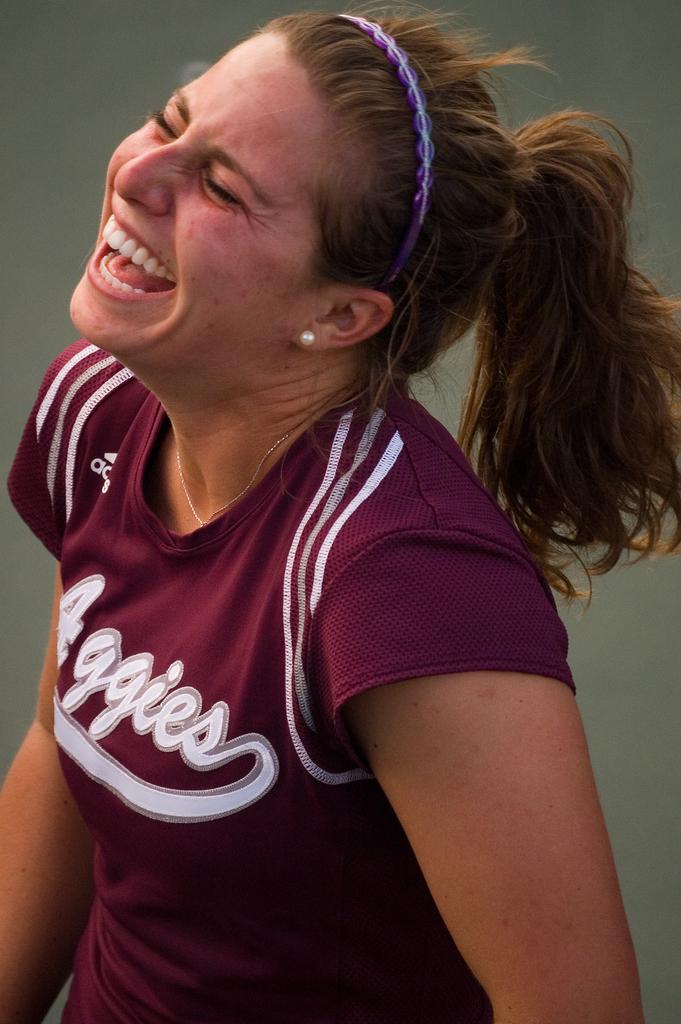What does her shirt say?
Ensure brevity in your answer.  Aggies. 